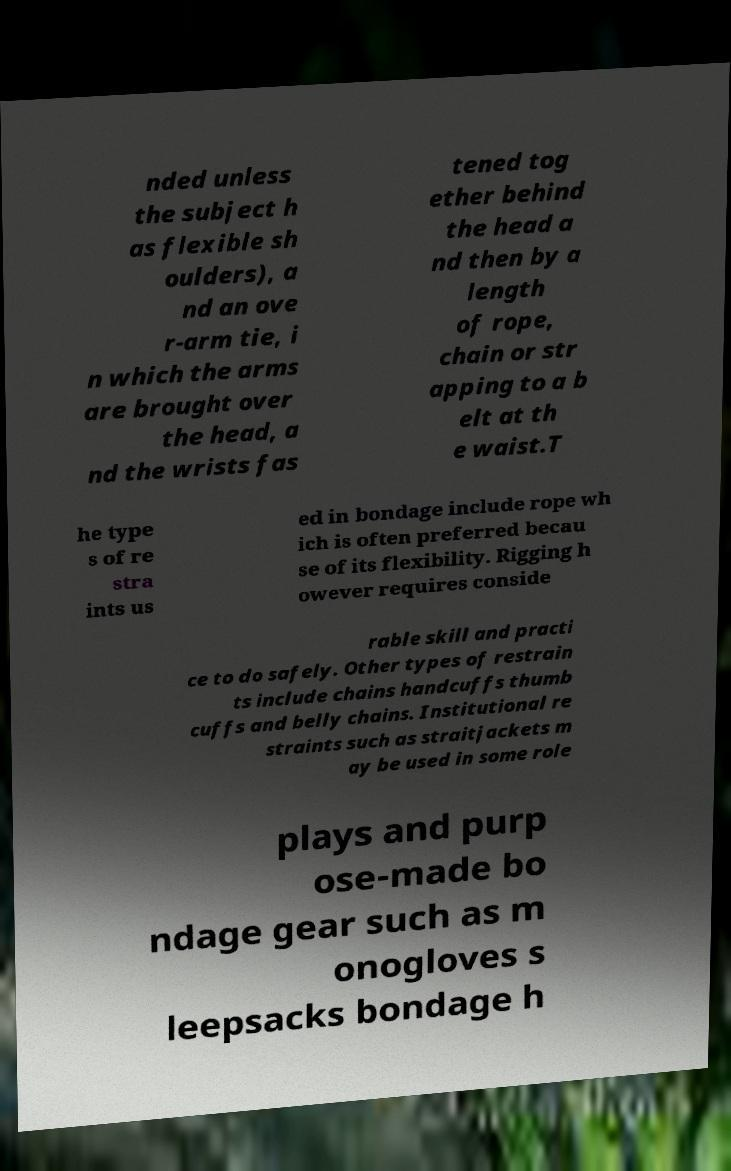For documentation purposes, I need the text within this image transcribed. Could you provide that? nded unless the subject h as flexible sh oulders), a nd an ove r-arm tie, i n which the arms are brought over the head, a nd the wrists fas tened tog ether behind the head a nd then by a length of rope, chain or str apping to a b elt at th e waist.T he type s of re stra ints us ed in bondage include rope wh ich is often preferred becau se of its flexibility. Rigging h owever requires conside rable skill and practi ce to do safely. Other types of restrain ts include chains handcuffs thumb cuffs and belly chains. Institutional re straints such as straitjackets m ay be used in some role plays and purp ose-made bo ndage gear such as m onogloves s leepsacks bondage h 